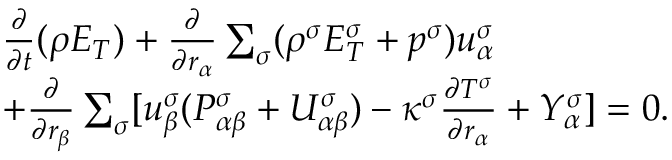<formula> <loc_0><loc_0><loc_500><loc_500>\begin{array} { r } { \begin{array} { r l } & { \frac { \partial } { \partial t } ( \rho E _ { T } ) + \frac { \partial } { \partial r _ { \alpha } } \sum _ { \sigma } ( \rho ^ { \sigma } E _ { T } ^ { \sigma } + p ^ { \sigma } ) u _ { \alpha } ^ { \sigma } } \\ & { + \frac { \partial } { \partial r _ { \beta } } \sum _ { \sigma } [ u _ { \beta } ^ { \sigma } ( P _ { \alpha \beta } ^ { \sigma } + U _ { \alpha \beta } ^ { \sigma } ) - \kappa ^ { \sigma } \frac { \partial T ^ { \sigma } } { \partial r _ { \alpha } } + Y _ { \alpha } ^ { \sigma } ] = 0 . } \end{array} } \end{array}</formula> 